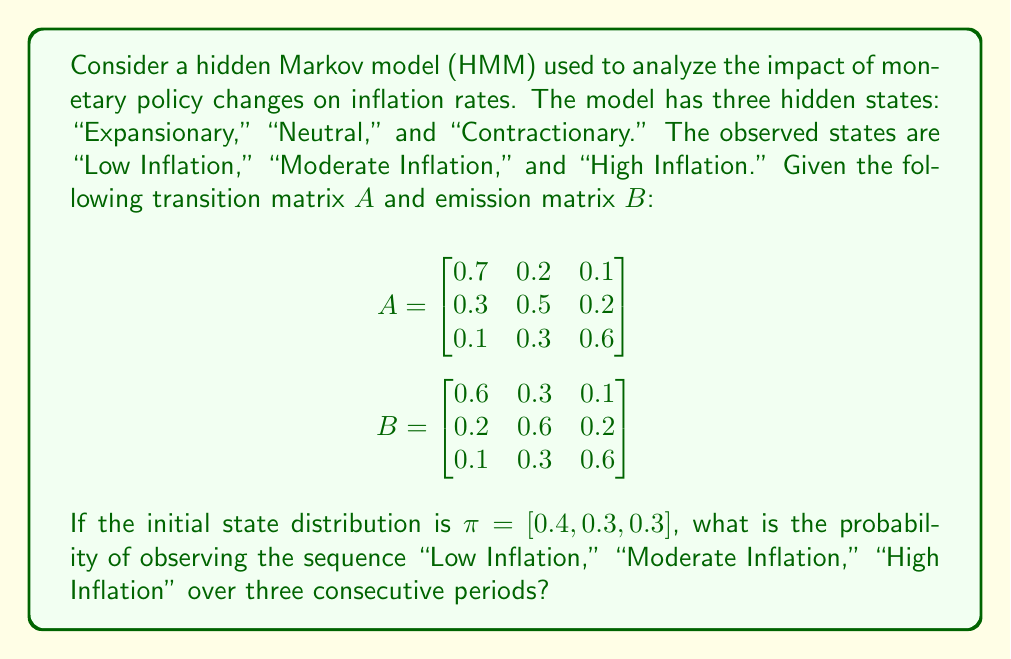Provide a solution to this math problem. To solve this problem, we'll use the forward algorithm for HMMs. Let's break it down step-by-step:

1) Define the forward variable $\alpha_t(i)$ as the probability of observing the partial sequence up to time $t$ and being in state $i$ at time $t$.

2) Initialize the forward variables:
   $\alpha_1(i) = \pi_i b_i(O_1)$, where $O_1$ is "Low Inflation"
   
   $\alpha_1(1) = 0.4 \times 0.6 = 0.24$
   $\alpha_1(2) = 0.3 \times 0.2 = 0.06$
   $\alpha_1(3) = 0.3 \times 0.1 = 0.03$

3) Recursively calculate $\alpha_t(j)$ for $t = 2, 3$:
   $\alpha_t(j) = [\sum_{i=1}^3 \alpha_{t-1}(i)a_{ij}]b_j(O_t)$

   For $t = 2$ (Moderate Inflation):
   $\alpha_2(1) = [(0.24 \times 0.7) + (0.06 \times 0.3) + (0.03 \times 0.1)] \times 0.3 = 0.0549$
   $\alpha_2(2) = [(0.24 \times 0.2) + (0.06 \times 0.5) + (0.03 \times 0.3)] \times 0.6 = 0.0456$
   $\alpha_2(3) = [(0.24 \times 0.1) + (0.06 \times 0.2) + (0.03 \times 0.6)] \times 0.2 = 0.0078$

   For $t = 3$ (High Inflation):
   $\alpha_3(1) = [(0.0549 \times 0.7) + (0.0456 \times 0.3) + (0.0078 \times 0.1)] \times 0.1 = 0.00532$
   $\alpha_3(2) = [(0.0549 \times 0.2) + (0.0456 \times 0.5) + (0.0078 \times 0.3)] \times 0.2 = 0.00304$
   $\alpha_3(3) = [(0.0549 \times 0.1) + (0.0456 \times 0.2) + (0.0078 \times 0.6)] \times 0.6 = 0.00702$

4) The probability of the observed sequence is the sum of the final forward variables:
   $P(O) = \sum_{i=1}^3 \alpha_3(i) = 0.00532 + 0.00304 + 0.00702 = 0.01538$
Answer: 0.01538 